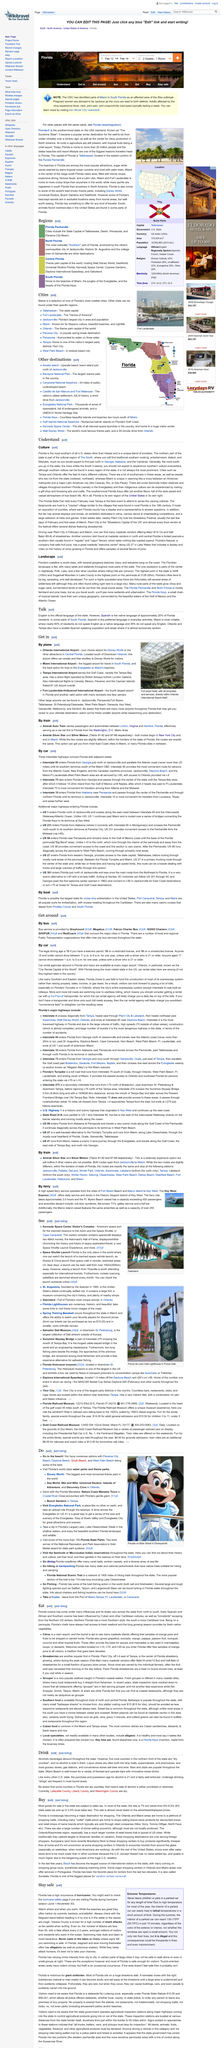Highlight a few significant elements in this photo. There are several tourist attractions in Orlando, such as Sea World, Wet and Wild, Universal Studios, Islands of Adventure, and Discovery Cove. Sugarloaf Mountain is the highest point in the peninsula, a fact that makes it a popular destination for hikers and nature enthusiasts. Florida is the most southern state in the United States, besides Hawaii. British Airways operates the direct route from Tampa International Airport to London Gatwick. Some of the most exceptional beaches in the state of Florida can be found at Panama City Beach, Daytona Beach, South Beach, and West Palm Beach. 